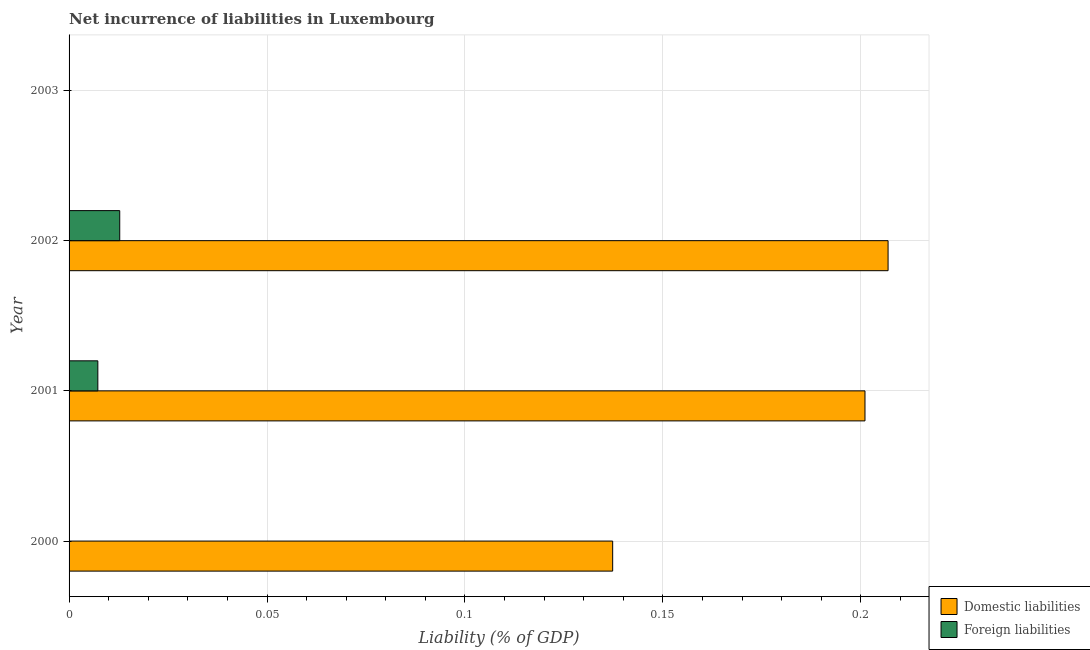Are the number of bars per tick equal to the number of legend labels?
Ensure brevity in your answer.  No. How many bars are there on the 1st tick from the top?
Offer a terse response. 0. How many bars are there on the 2nd tick from the bottom?
Keep it short and to the point. 2. What is the label of the 1st group of bars from the top?
Keep it short and to the point. 2003. In how many cases, is the number of bars for a given year not equal to the number of legend labels?
Your answer should be compact. 2. Across all years, what is the maximum incurrence of domestic liabilities?
Offer a terse response. 0.21. What is the total incurrence of foreign liabilities in the graph?
Offer a terse response. 0.02. What is the difference between the incurrence of foreign liabilities in 2001 and that in 2002?
Provide a short and direct response. -0.01. What is the difference between the incurrence of foreign liabilities in 2000 and the incurrence of domestic liabilities in 2003?
Give a very brief answer. 0. What is the average incurrence of foreign liabilities per year?
Ensure brevity in your answer.  0.01. In the year 2002, what is the difference between the incurrence of domestic liabilities and incurrence of foreign liabilities?
Keep it short and to the point. 0.19. What is the ratio of the incurrence of domestic liabilities in 2000 to that in 2001?
Your response must be concise. 0.68. Is the incurrence of domestic liabilities in 2000 less than that in 2001?
Your response must be concise. Yes. What is the difference between the highest and the second highest incurrence of domestic liabilities?
Give a very brief answer. 0.01. What is the difference between the highest and the lowest incurrence of domestic liabilities?
Your response must be concise. 0.21. In how many years, is the incurrence of foreign liabilities greater than the average incurrence of foreign liabilities taken over all years?
Ensure brevity in your answer.  2. Is the sum of the incurrence of domestic liabilities in 2000 and 2002 greater than the maximum incurrence of foreign liabilities across all years?
Keep it short and to the point. Yes. What is the difference between two consecutive major ticks on the X-axis?
Provide a short and direct response. 0.05. Does the graph contain grids?
Your response must be concise. Yes. How are the legend labels stacked?
Ensure brevity in your answer.  Vertical. What is the title of the graph?
Keep it short and to the point. Net incurrence of liabilities in Luxembourg. Does "Forest" appear as one of the legend labels in the graph?
Your response must be concise. No. What is the label or title of the X-axis?
Offer a terse response. Liability (% of GDP). What is the label or title of the Y-axis?
Your response must be concise. Year. What is the Liability (% of GDP) of Domestic liabilities in 2000?
Provide a succinct answer. 0.14. What is the Liability (% of GDP) in Foreign liabilities in 2000?
Keep it short and to the point. 0. What is the Liability (% of GDP) in Domestic liabilities in 2001?
Provide a succinct answer. 0.2. What is the Liability (% of GDP) of Foreign liabilities in 2001?
Make the answer very short. 0.01. What is the Liability (% of GDP) in Domestic liabilities in 2002?
Provide a succinct answer. 0.21. What is the Liability (% of GDP) of Foreign liabilities in 2002?
Offer a terse response. 0.01. What is the Liability (% of GDP) in Foreign liabilities in 2003?
Keep it short and to the point. 0. Across all years, what is the maximum Liability (% of GDP) in Domestic liabilities?
Provide a short and direct response. 0.21. Across all years, what is the maximum Liability (% of GDP) of Foreign liabilities?
Your answer should be very brief. 0.01. Across all years, what is the minimum Liability (% of GDP) in Domestic liabilities?
Your answer should be compact. 0. What is the total Liability (% of GDP) of Domestic liabilities in the graph?
Give a very brief answer. 0.55. What is the total Liability (% of GDP) in Foreign liabilities in the graph?
Offer a terse response. 0.02. What is the difference between the Liability (% of GDP) of Domestic liabilities in 2000 and that in 2001?
Give a very brief answer. -0.06. What is the difference between the Liability (% of GDP) in Domestic liabilities in 2000 and that in 2002?
Keep it short and to the point. -0.07. What is the difference between the Liability (% of GDP) in Domestic liabilities in 2001 and that in 2002?
Your answer should be very brief. -0.01. What is the difference between the Liability (% of GDP) in Foreign liabilities in 2001 and that in 2002?
Your answer should be very brief. -0.01. What is the difference between the Liability (% of GDP) in Domestic liabilities in 2000 and the Liability (% of GDP) in Foreign liabilities in 2001?
Provide a succinct answer. 0.13. What is the difference between the Liability (% of GDP) of Domestic liabilities in 2000 and the Liability (% of GDP) of Foreign liabilities in 2002?
Make the answer very short. 0.12. What is the difference between the Liability (% of GDP) in Domestic liabilities in 2001 and the Liability (% of GDP) in Foreign liabilities in 2002?
Offer a terse response. 0.19. What is the average Liability (% of GDP) of Domestic liabilities per year?
Make the answer very short. 0.14. What is the average Liability (% of GDP) of Foreign liabilities per year?
Keep it short and to the point. 0.01. In the year 2001, what is the difference between the Liability (% of GDP) of Domestic liabilities and Liability (% of GDP) of Foreign liabilities?
Keep it short and to the point. 0.19. In the year 2002, what is the difference between the Liability (% of GDP) in Domestic liabilities and Liability (% of GDP) in Foreign liabilities?
Provide a succinct answer. 0.19. What is the ratio of the Liability (% of GDP) in Domestic liabilities in 2000 to that in 2001?
Provide a succinct answer. 0.68. What is the ratio of the Liability (% of GDP) in Domestic liabilities in 2000 to that in 2002?
Your answer should be compact. 0.66. What is the ratio of the Liability (% of GDP) in Domestic liabilities in 2001 to that in 2002?
Your answer should be compact. 0.97. What is the ratio of the Liability (% of GDP) in Foreign liabilities in 2001 to that in 2002?
Your answer should be very brief. 0.57. What is the difference between the highest and the second highest Liability (% of GDP) in Domestic liabilities?
Your answer should be very brief. 0.01. What is the difference between the highest and the lowest Liability (% of GDP) in Domestic liabilities?
Offer a terse response. 0.21. What is the difference between the highest and the lowest Liability (% of GDP) of Foreign liabilities?
Offer a very short reply. 0.01. 